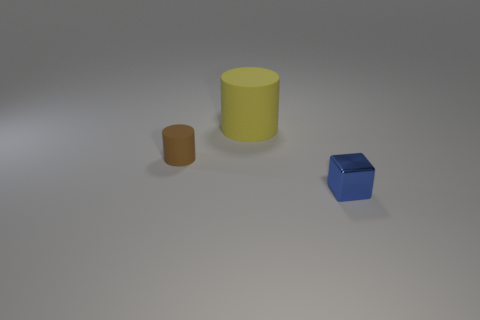What could these shapes represent if we imagine a symbolic meaning? The shapes could symbolize different aspects of structure and stability. The cylinder could represent pillars or foundational elements, providing support, while the cube might symbolize order and rigidity, displaying the various ways that fundamental shapes contribute to our understanding of stability and efficiency. 